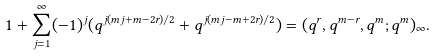<formula> <loc_0><loc_0><loc_500><loc_500>1 + \sum _ { j = 1 } ^ { \infty } ( - 1 ) ^ { j } ( q ^ { j ( m j + m - 2 r ) / 2 } + q ^ { j ( m j - m + 2 r ) / 2 } ) = ( q ^ { r } , q ^ { m - r } , q ^ { m } ; q ^ { m } ) _ { \infty } .</formula> 